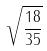<formula> <loc_0><loc_0><loc_500><loc_500>\sqrt { \frac { 1 8 } { 3 5 } }</formula> 